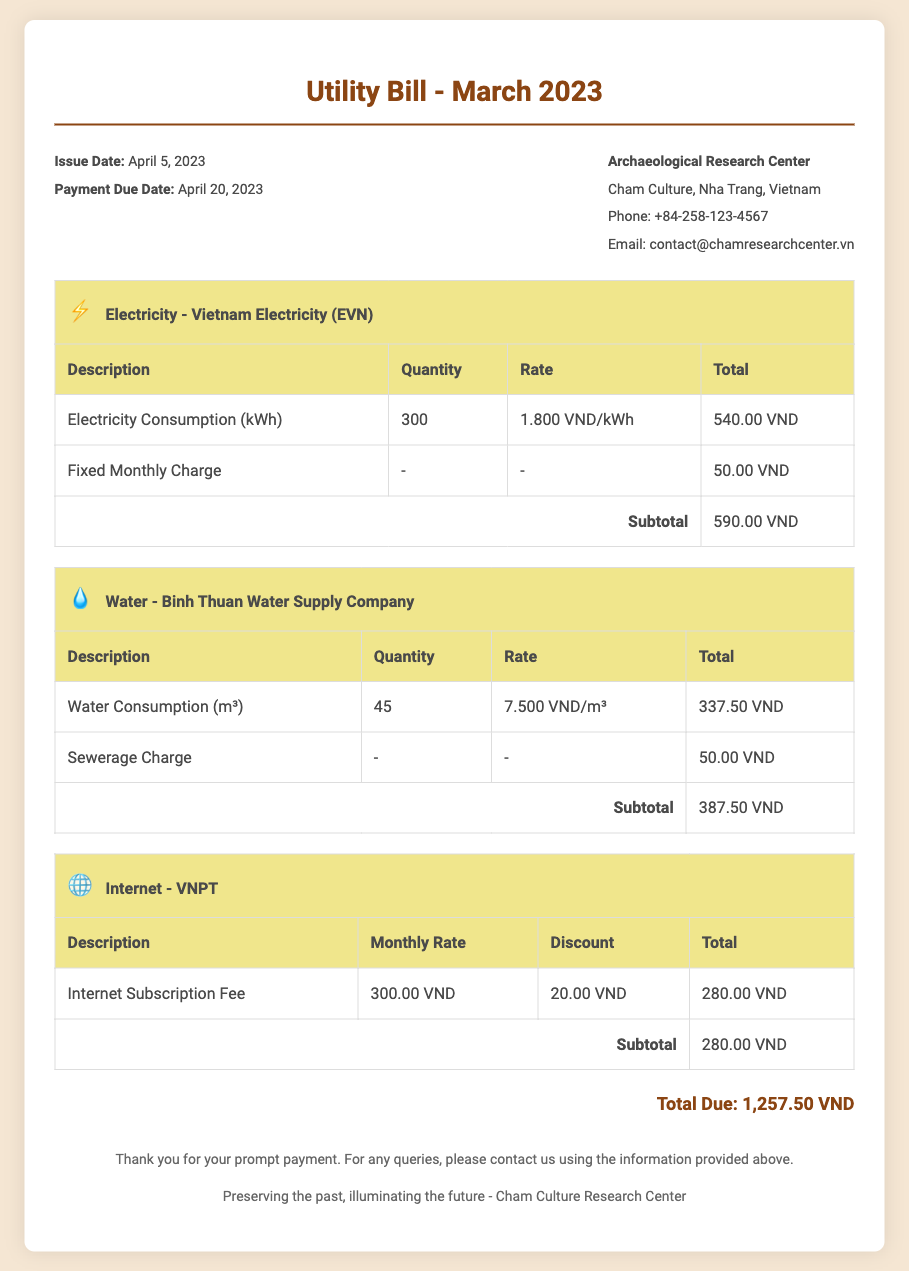What is the issue date of the bill? The issue date of the bill is indicated at the top of the document.
Answer: April 5, 2023 How much was the electricity consumption? The electricity consumption is mentioned in the electricity section of the bill.
Answer: 300 kWh What is the total amount due for the bill? The total amount due is summarized at the bottom of the document.
Answer: 1,257.50 VND What is the water consumption charge? The charge for water consumption is detailed in the water section.
Answer: 337.50 VND What is the discount given for the internet service? The discount for internet service is specified in the internet section of the bill.
Answer: 20.00 VND Who is the provider for the internet service? The bill specifies the name of the internet service provider.
Answer: VNPT How many cubic meters of water were consumed? The quantity of water consumed is stated in the water section.
Answer: 45 m³ What is the fixed monthly charge for electricity? The fixed monthly charge is listed in the electricity section.
Answer: 50.00 VND What date is the payment due? The payment due date is provided in the bill information section.
Answer: April 20, 2023 